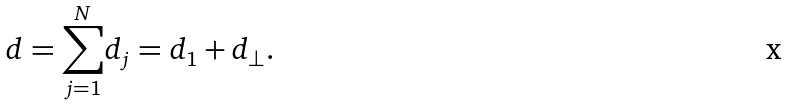Convert formula to latex. <formula><loc_0><loc_0><loc_500><loc_500>d = \underset { j = 1 } { \overset { N } { \sum } } d _ { j } = d _ { 1 } + d _ { \perp } .</formula> 